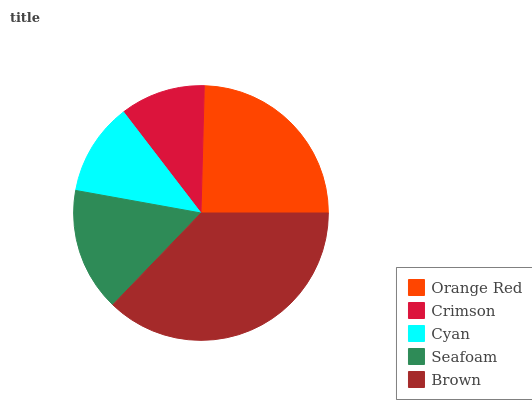Is Crimson the minimum?
Answer yes or no. Yes. Is Brown the maximum?
Answer yes or no. Yes. Is Cyan the minimum?
Answer yes or no. No. Is Cyan the maximum?
Answer yes or no. No. Is Cyan greater than Crimson?
Answer yes or no. Yes. Is Crimson less than Cyan?
Answer yes or no. Yes. Is Crimson greater than Cyan?
Answer yes or no. No. Is Cyan less than Crimson?
Answer yes or no. No. Is Seafoam the high median?
Answer yes or no. Yes. Is Seafoam the low median?
Answer yes or no. Yes. Is Crimson the high median?
Answer yes or no. No. Is Orange Red the low median?
Answer yes or no. No. 